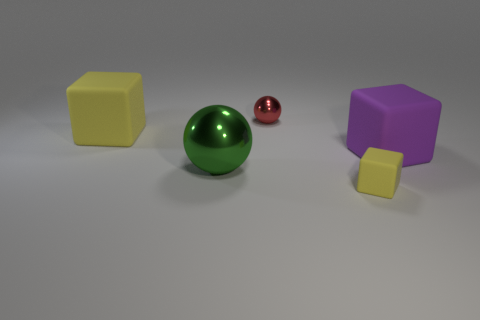Can you describe the smallest object shown in the image? Certainly! The smallest object in the image is a sphere with a reflective red surface. Its size is comparable to the one of the larger spheres but noticeably smaller, suggesting a scaled-down version. 